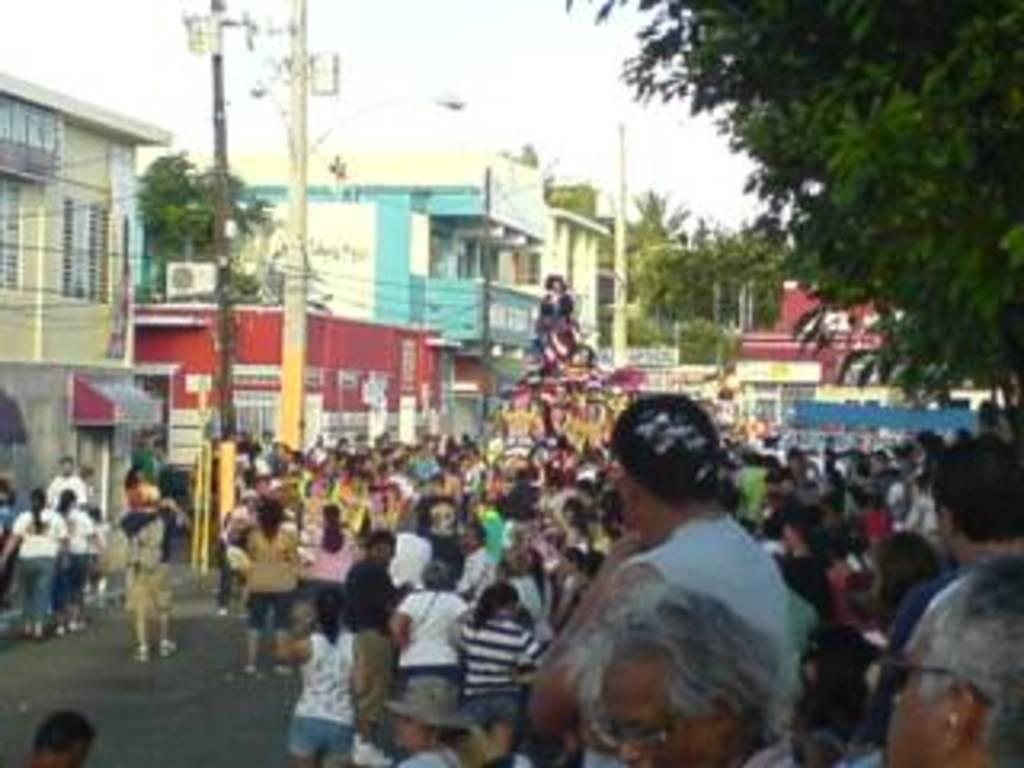How many people are in the image? There is a group of people in the image. What type of natural elements can be seen in the image? There are trees in the image. What type of man-made structures are visible in the image? There are buildings in the image. What type of infrastructure is present in the image? Electric poles are visible in the image. What other objects can be seen in the image? There are objects in the image. What is visible in the background of the image? The sky is visible in the background of the image. Can you tell me where the queen is standing in the image? There is no queen present in the image. What type of bird is depicted on the flag in the image? There is no flag present in the image. 